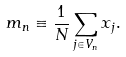<formula> <loc_0><loc_0><loc_500><loc_500>m _ { n } \equiv \frac { 1 } { N } \sum _ { j \in V _ { n } } x _ { j } .</formula> 